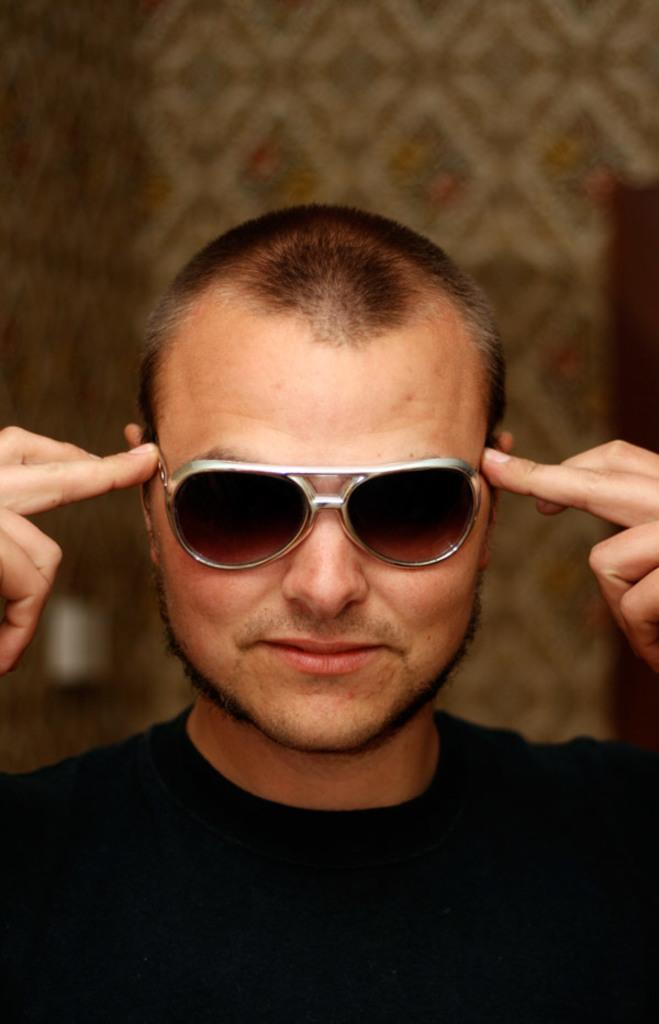Who is present in the image? There is a man in the image. What can be observed about the man's appearance? The man is wearing glasses and a black color t-shirt. What is the man's facial expression? The man is smiling. Can you describe the background of the image? The background of the image is not clear. What memory does the man have of his uncle in the image? There is no mention of an uncle or any memory in the image. The image only shows a man wearing glasses, a black t-shirt, and smiling. 